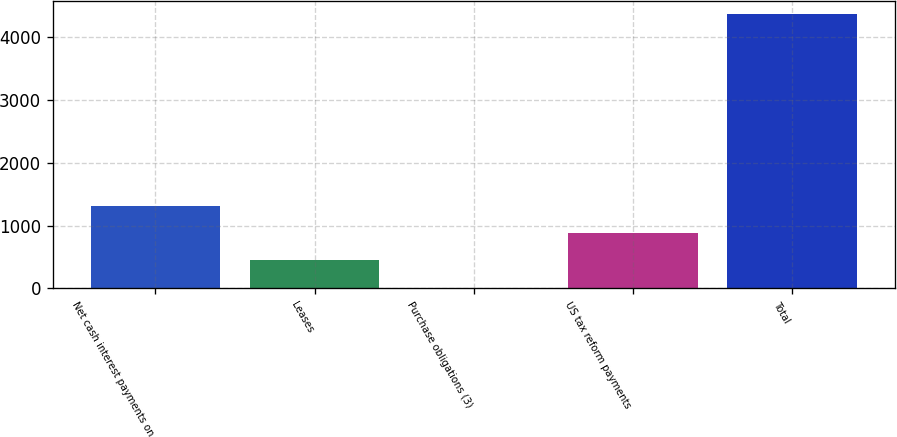Convert chart to OTSL. <chart><loc_0><loc_0><loc_500><loc_500><bar_chart><fcel>Net cash interest payments on<fcel>Leases<fcel>Purchase obligations (3)<fcel>US tax reform payments<fcel>Total<nl><fcel>1313.5<fcel>444.5<fcel>10<fcel>879<fcel>4355<nl></chart> 